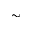<formula> <loc_0><loc_0><loc_500><loc_500>\sim</formula> 